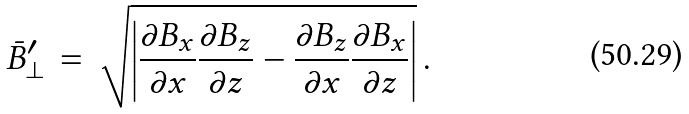<formula> <loc_0><loc_0><loc_500><loc_500>\bar { B } _ { \perp } ^ { \prime } \, = \, \sqrt { \left | \frac { \partial B _ { x } } { \partial x } \frac { \partial B _ { z } } { \partial z } - \frac { \partial B _ { z } } { \partial x } \frac { \partial B _ { x } } { \partial z } \right | } \, .</formula> 